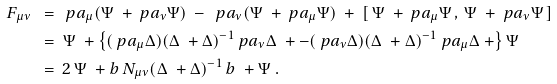Convert formula to latex. <formula><loc_0><loc_0><loc_500><loc_500>F _ { \mu \nu } \ & = \ \ p a _ { \mu } ( \Psi ^ { \ } + \ p a _ { \nu } \Psi ) \ - \ \ p a _ { \nu } ( \Psi ^ { \ } + \ p a _ { \mu } \Psi ) \ + \ [ \, \Psi ^ { \ } + \ p a _ { \mu } \Psi \, , \, \Psi ^ { \ } + \ p a _ { \nu } \Psi \, ] \\ & = \ \Psi ^ { \ } + \left \{ ( \ p a _ { \mu } \Delta ) ( \Delta ^ { \ } + \Delta ) ^ { - 1 } \ p a _ { \nu } \Delta ^ { \ } + - ( \ p a _ { \nu } \Delta ) ( \Delta ^ { \ } + \Delta ) ^ { - 1 } \ p a _ { \mu } \Delta ^ { \ } + \right \} \Psi \\ & = \ 2 \, \Psi ^ { \ } + { b } \, N _ { \mu \nu } ( \Delta ^ { \ } + \Delta ) ^ { - 1 } \, { b } ^ { \ } + \Psi \ .</formula> 